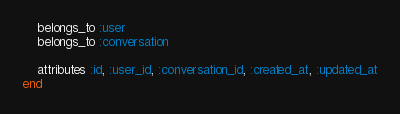<code> <loc_0><loc_0><loc_500><loc_500><_Ruby_>    belongs_to :user
    belongs_to :conversation

    attributes :id, :user_id, :conversation_id, :created_at, :updated_at
end</code> 